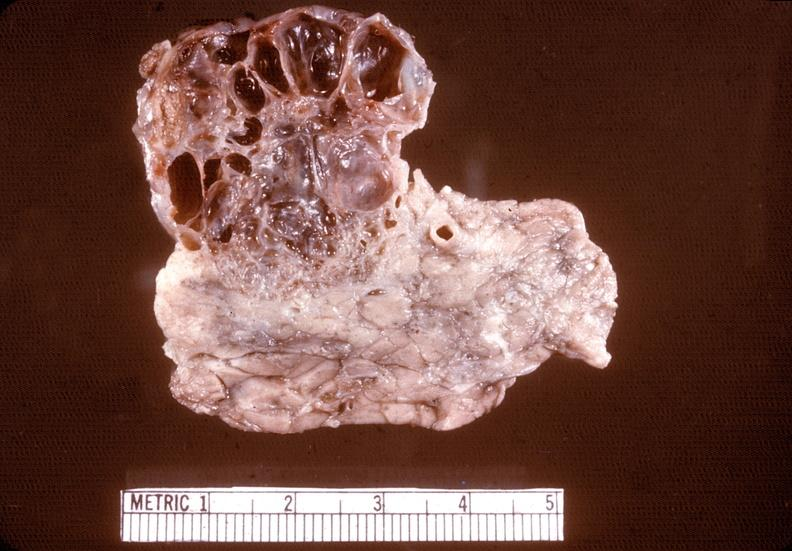s pancreas present?
Answer the question using a single word or phrase. Yes 